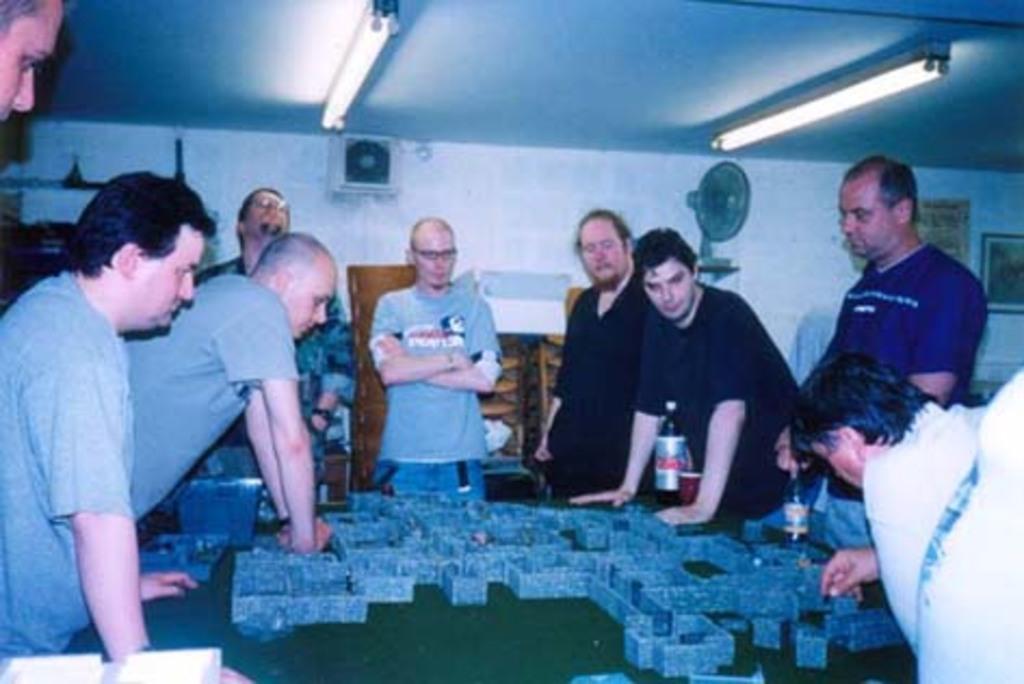Could you give a brief overview of what you see in this image? In the image we can see there are people standing and they are wearing clothes. Here we can see playing coins and bottles. We can even see lights, wall, table fan and frames stick to the wall. 